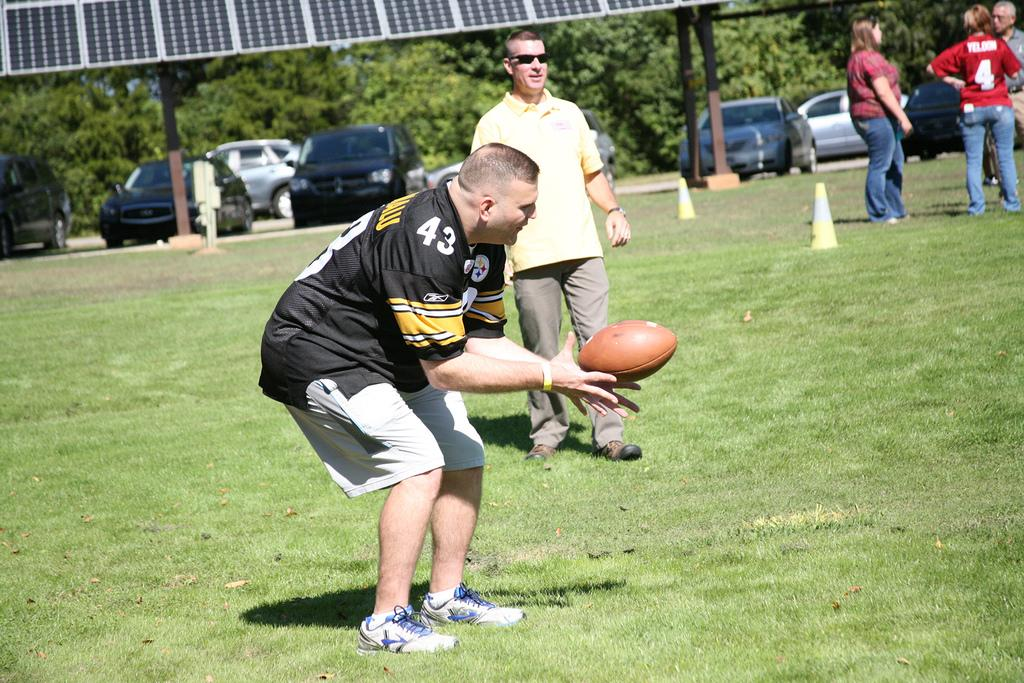<image>
Relay a brief, clear account of the picture shown. a man in a number 43 jersey holds a football 